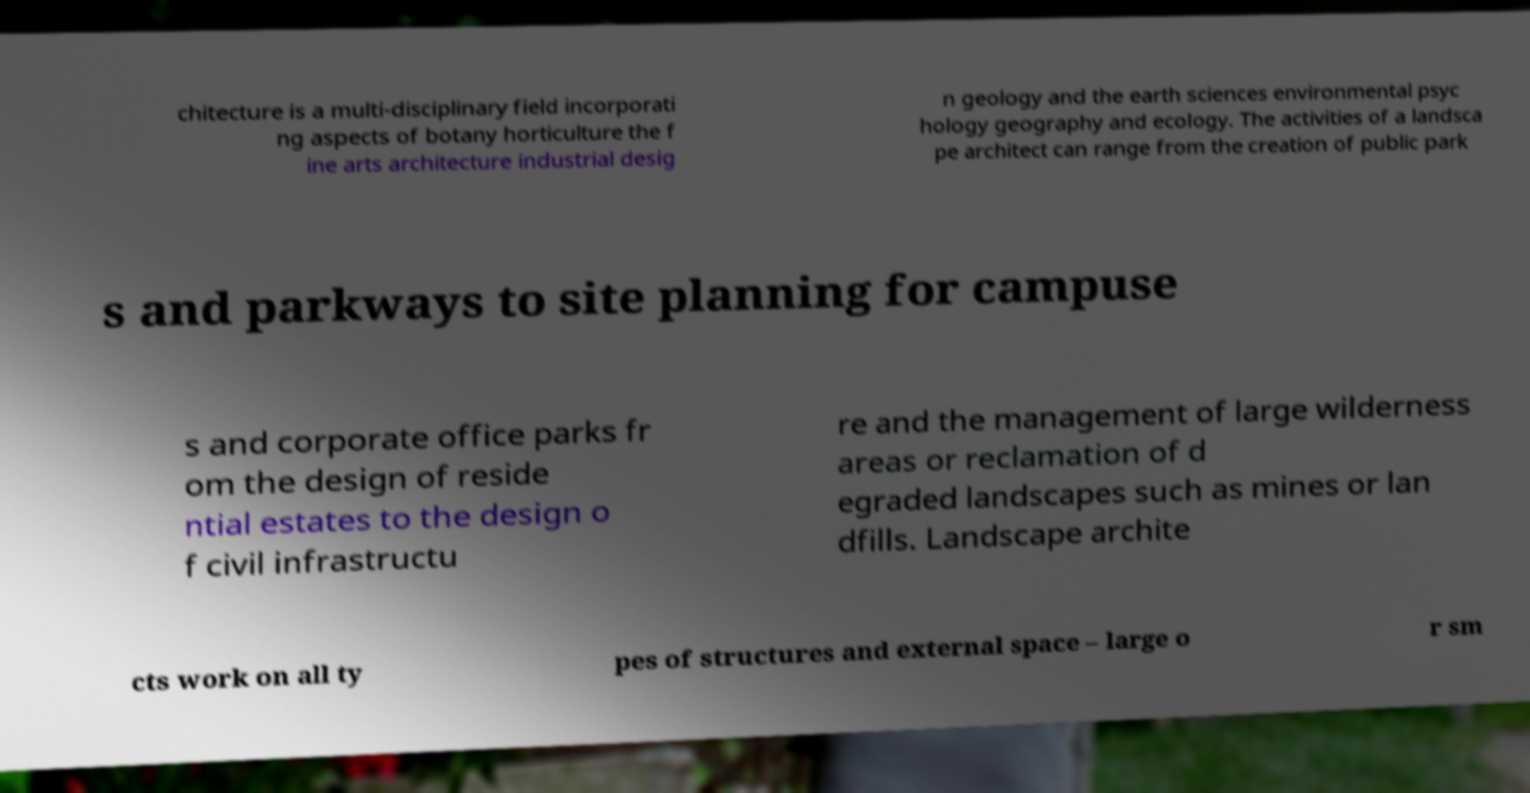Can you read and provide the text displayed in the image?This photo seems to have some interesting text. Can you extract and type it out for me? chitecture is a multi-disciplinary field incorporati ng aspects of botany horticulture the f ine arts architecture industrial desig n geology and the earth sciences environmental psyc hology geography and ecology. The activities of a landsca pe architect can range from the creation of public park s and parkways to site planning for campuse s and corporate office parks fr om the design of reside ntial estates to the design o f civil infrastructu re and the management of large wilderness areas or reclamation of d egraded landscapes such as mines or lan dfills. Landscape archite cts work on all ty pes of structures and external space – large o r sm 